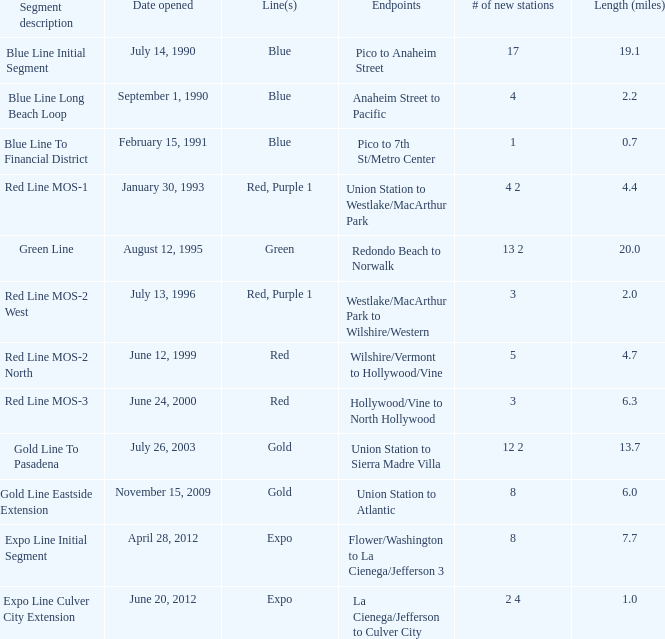What is the lenth (miles) of endpoints westlake/macarthur park to wilshire/western? 2.0. 